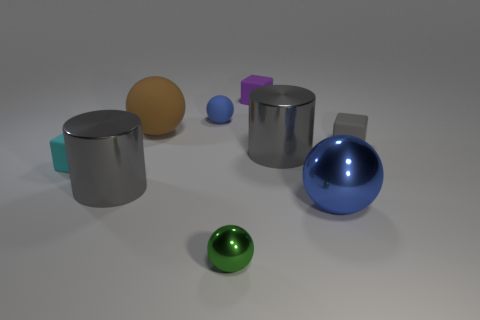What is the color of the small metal object?
Keep it short and to the point. Green. What is the shape of the cyan thing that is made of the same material as the purple cube?
Offer a terse response. Cube. Does the metallic cylinder that is to the left of the purple matte block have the same size as the big rubber object?
Offer a terse response. Yes. What number of objects are either balls in front of the blue matte ball or metal objects that are to the right of the small blue matte sphere?
Offer a very short reply. 4. Do the large sphere on the right side of the small metallic object and the tiny matte ball have the same color?
Keep it short and to the point. Yes. What number of metal objects are cylinders or blue things?
Make the answer very short. 3. What is the shape of the green metallic thing?
Provide a short and direct response. Sphere. Does the purple object have the same material as the small cyan object?
Ensure brevity in your answer.  Yes. There is a small sphere that is behind the cylinder that is left of the green object; are there any blue matte balls in front of it?
Your answer should be very brief. No. What number of other things are there of the same shape as the large brown thing?
Offer a terse response. 3. 